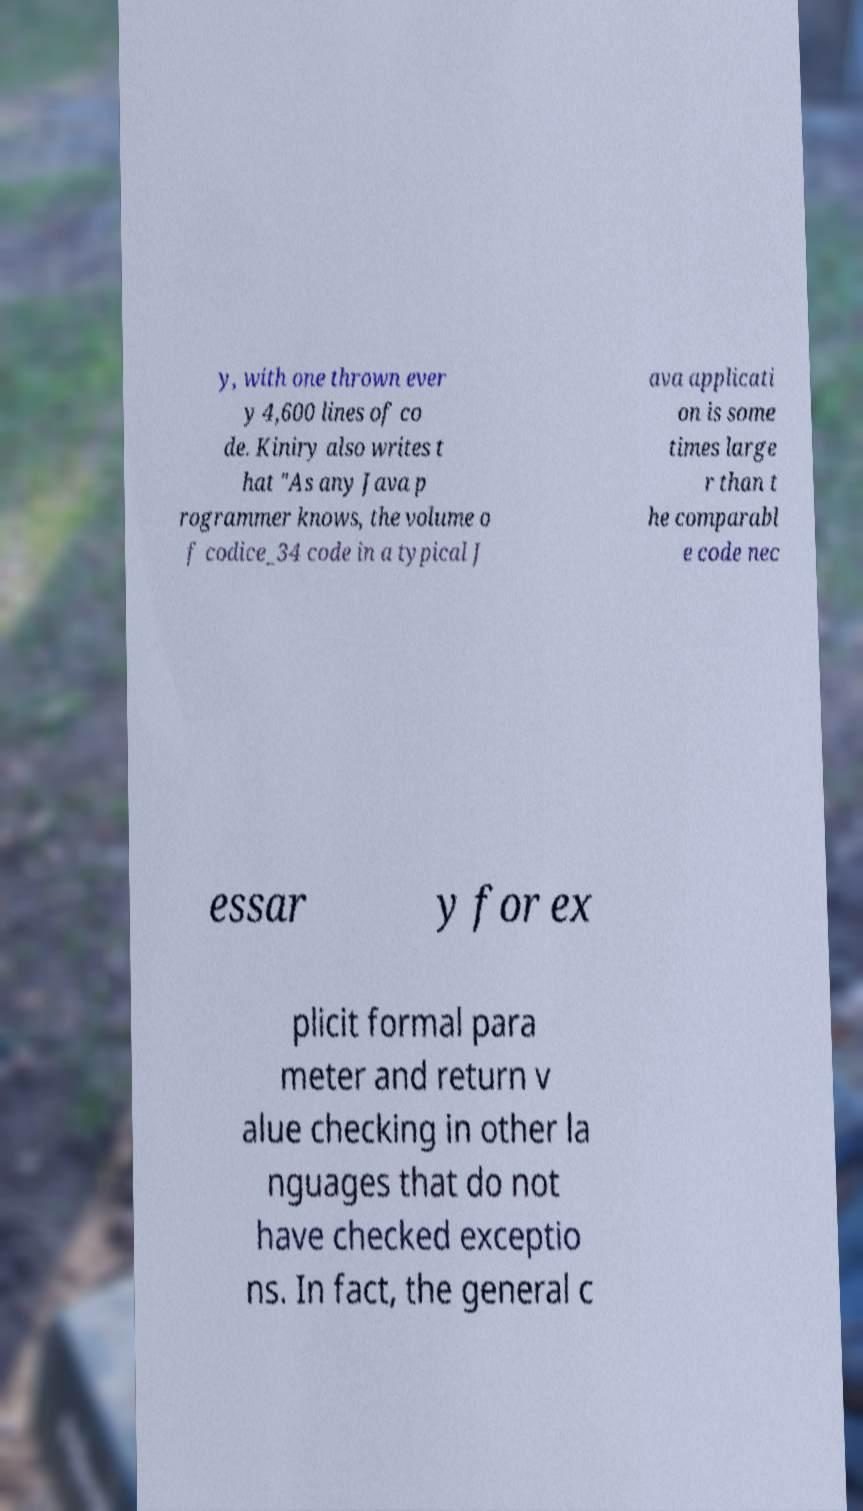For documentation purposes, I need the text within this image transcribed. Could you provide that? y, with one thrown ever y 4,600 lines of co de. Kiniry also writes t hat "As any Java p rogrammer knows, the volume o f codice_34 code in a typical J ava applicati on is some times large r than t he comparabl e code nec essar y for ex plicit formal para meter and return v alue checking in other la nguages that do not have checked exceptio ns. In fact, the general c 